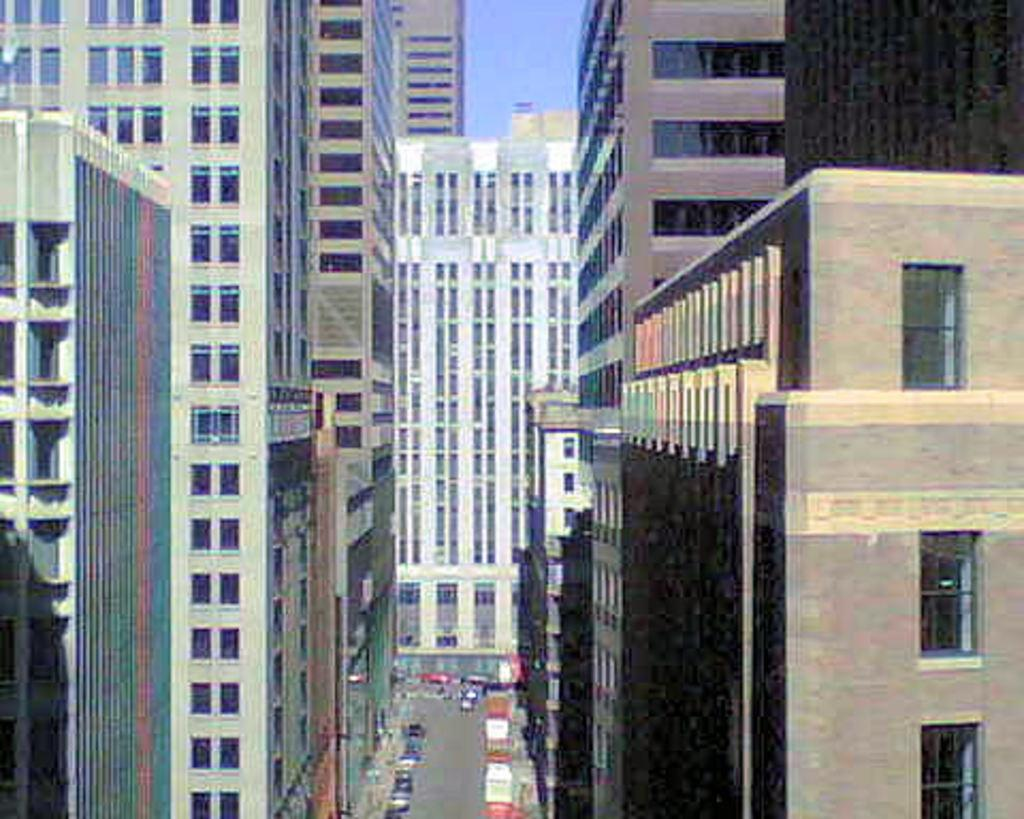What type of structures are present in the image? There are buildings with windows in the image. What can be seen on the ground in the image? There is a road visible in the image. What type of transportation is present in the image? There are vehicles in the image. What is visible above the ground in the image? The sky is visible in the image. How many rings are visible on the vehicles in the image? There are no rings mentioned or visible on the vehicles in the image. What type of soda is being served in the buildings in the image? There is no mention or indication of soda being served or present in the image. 